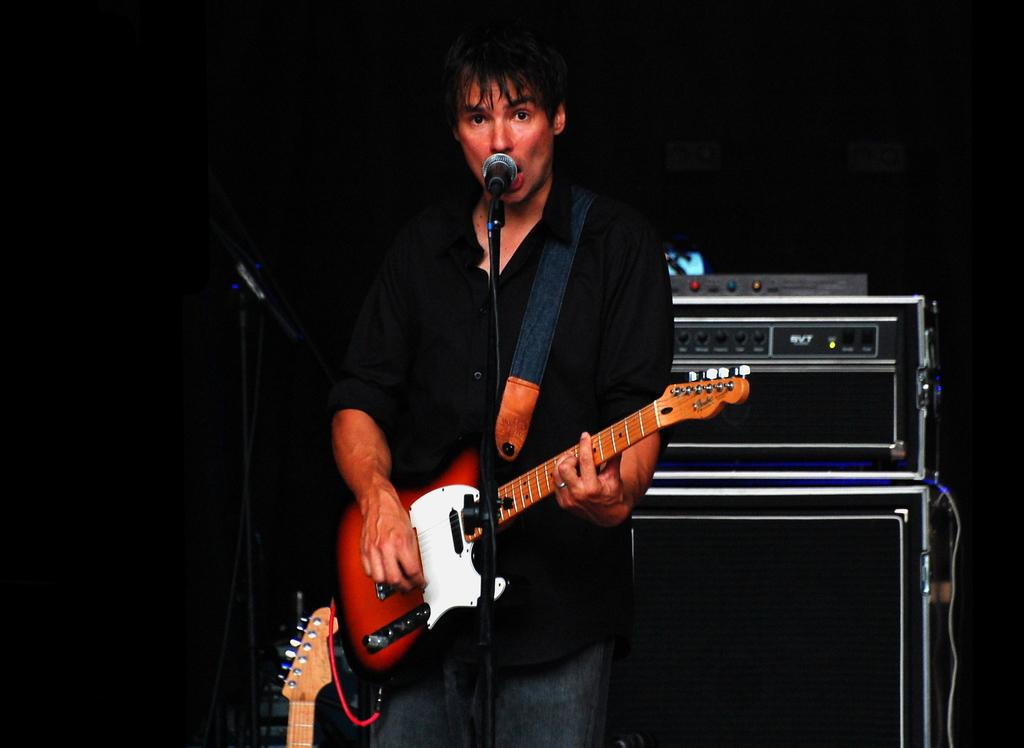What is the man in the image doing? The man is standing in front of a mic and holding a guitar. What can be seen near the man in the image? There is equipment in the background of the image. What else is present in the background of the image? There are other musical instruments in the background of the image. What type of polish is the man applying to his guitar in the image? There is no indication in the image that the man is applying any polish to his guitar. Can you tell me where the camp is located in the image? There is no camp present in the image. 